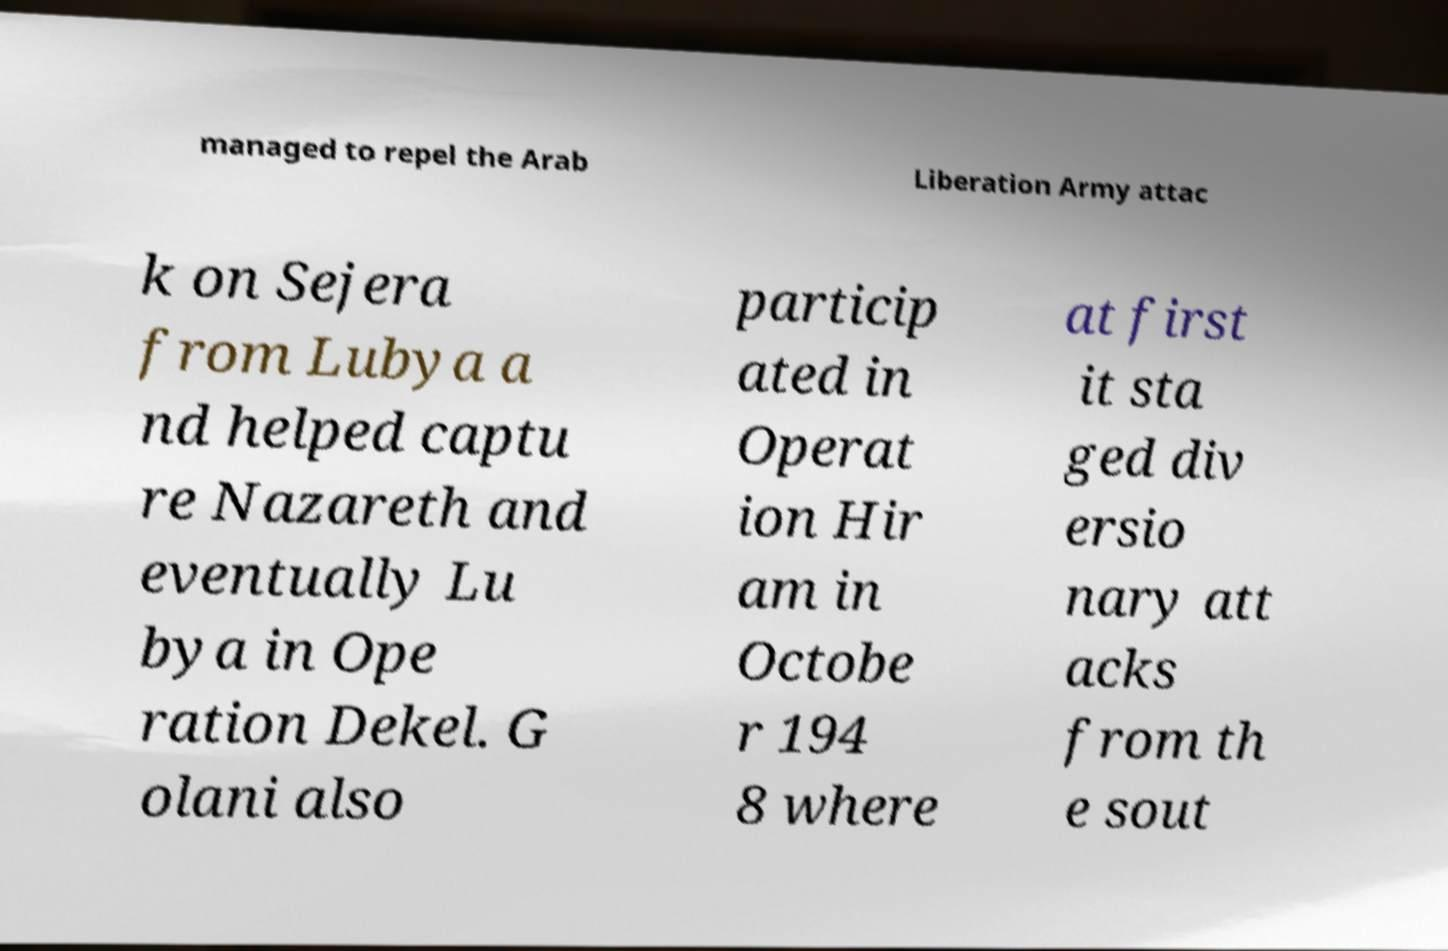For documentation purposes, I need the text within this image transcribed. Could you provide that? managed to repel the Arab Liberation Army attac k on Sejera from Lubya a nd helped captu re Nazareth and eventually Lu bya in Ope ration Dekel. G olani also particip ated in Operat ion Hir am in Octobe r 194 8 where at first it sta ged div ersio nary att acks from th e sout 